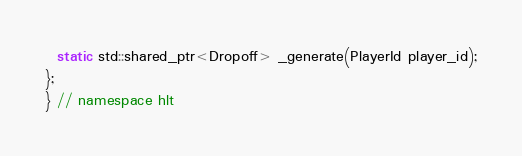<code> <loc_0><loc_0><loc_500><loc_500><_C++_>
  static std::shared_ptr<Dropoff> _generate(PlayerId player_id);
};
} // namespace hlt
</code> 